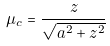Convert formula to latex. <formula><loc_0><loc_0><loc_500><loc_500>\mu _ { c } = \frac { z } { \sqrt { a ^ { 2 } + z ^ { 2 } } }</formula> 